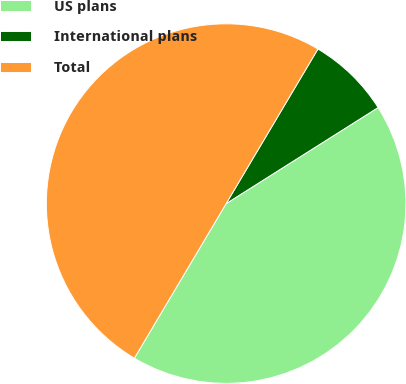Convert chart to OTSL. <chart><loc_0><loc_0><loc_500><loc_500><pie_chart><fcel>US plans<fcel>International plans<fcel>Total<nl><fcel>42.5%<fcel>7.5%<fcel>50.0%<nl></chart> 